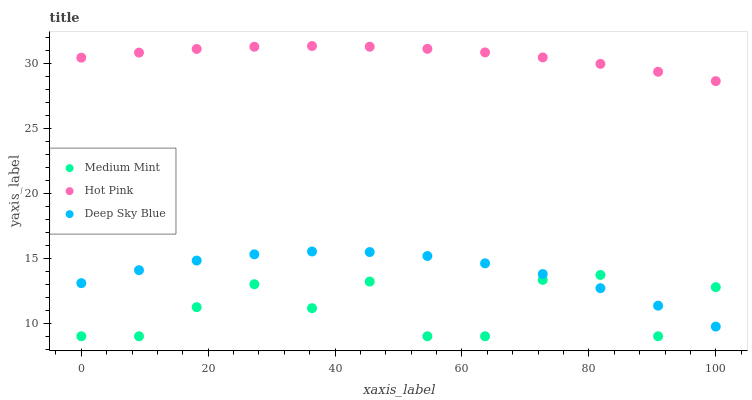Does Medium Mint have the minimum area under the curve?
Answer yes or no. Yes. Does Hot Pink have the maximum area under the curve?
Answer yes or no. Yes. Does Deep Sky Blue have the minimum area under the curve?
Answer yes or no. No. Does Deep Sky Blue have the maximum area under the curve?
Answer yes or no. No. Is Hot Pink the smoothest?
Answer yes or no. Yes. Is Medium Mint the roughest?
Answer yes or no. Yes. Is Deep Sky Blue the smoothest?
Answer yes or no. No. Is Deep Sky Blue the roughest?
Answer yes or no. No. Does Medium Mint have the lowest value?
Answer yes or no. Yes. Does Deep Sky Blue have the lowest value?
Answer yes or no. No. Does Hot Pink have the highest value?
Answer yes or no. Yes. Does Deep Sky Blue have the highest value?
Answer yes or no. No. Is Deep Sky Blue less than Hot Pink?
Answer yes or no. Yes. Is Hot Pink greater than Medium Mint?
Answer yes or no. Yes. Does Medium Mint intersect Deep Sky Blue?
Answer yes or no. Yes. Is Medium Mint less than Deep Sky Blue?
Answer yes or no. No. Is Medium Mint greater than Deep Sky Blue?
Answer yes or no. No. Does Deep Sky Blue intersect Hot Pink?
Answer yes or no. No. 